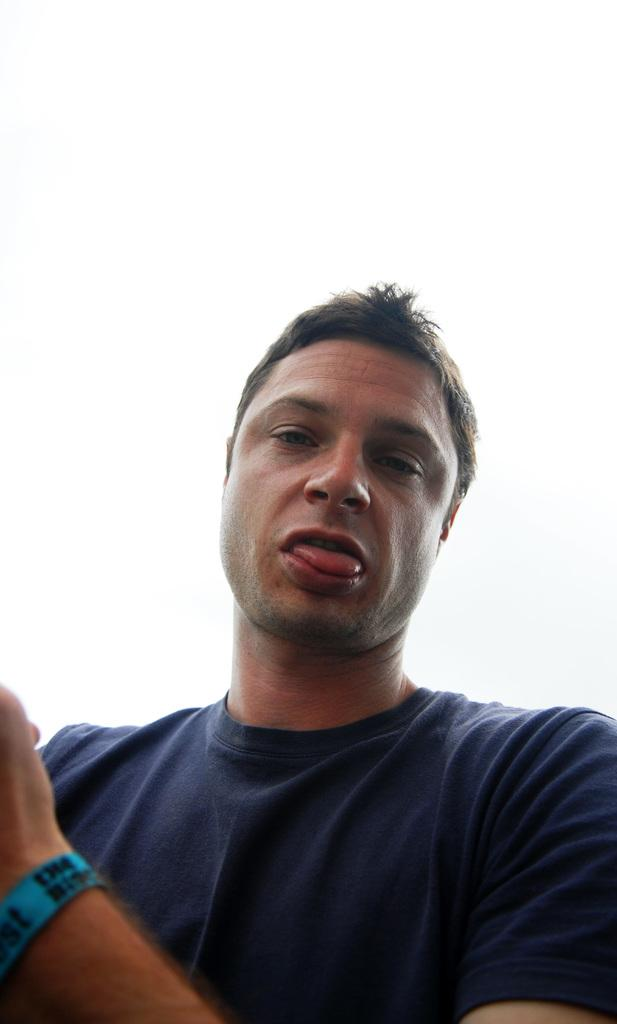Who is present in the image? There is a man in the image. What is the man wearing? The man is wearing a blue T-shirt. What color is the background of the image? The background of the image is white. What type of stove is visible in the image? There is no stove present in the image. How many people are performing in the show in the image? There is no show or performance depicted in the image. 